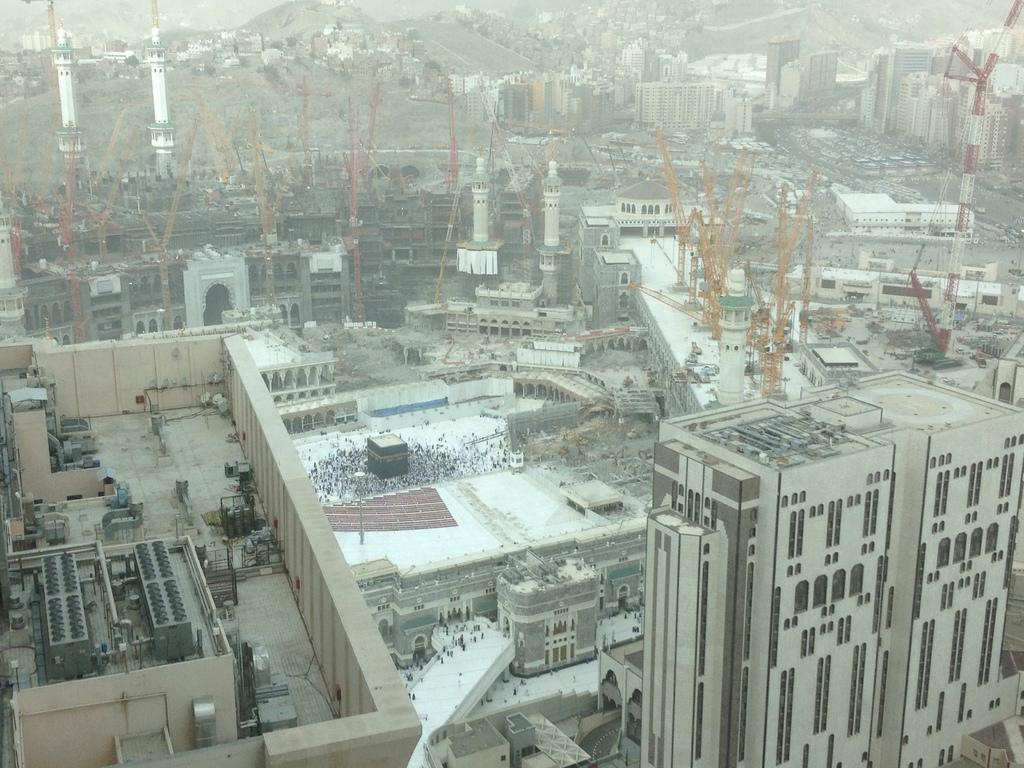What type of structures can be seen in the image? There are buildings in the image. What are the people in the image doing? The persons are standing before a pillar. What can be seen in the distance at the top of the image? There are hills visible at the top of the image. What type of machinery is present between the buildings? There are cranes present between the buildings. What type of steam is coming out of the bean in the image? There is no bean or steam present in the image. 